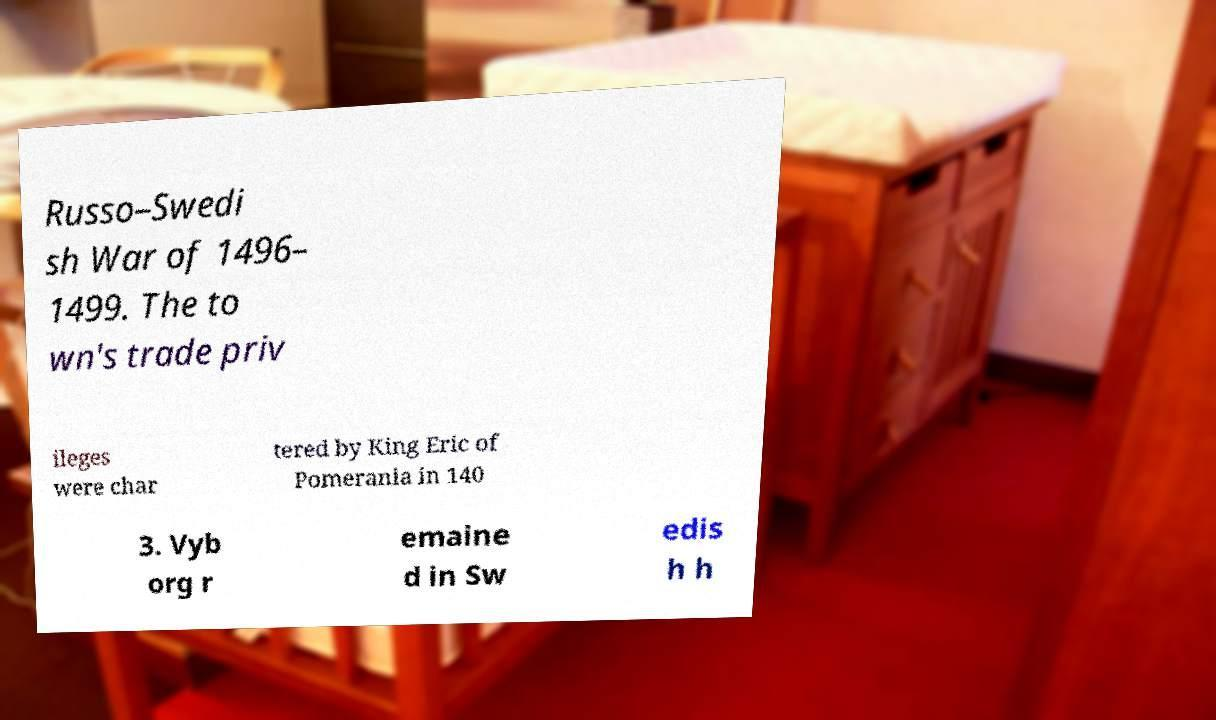Please identify and transcribe the text found in this image. Russo–Swedi sh War of 1496– 1499. The to wn's trade priv ileges were char tered by King Eric of Pomerania in 140 3. Vyb org r emaine d in Sw edis h h 